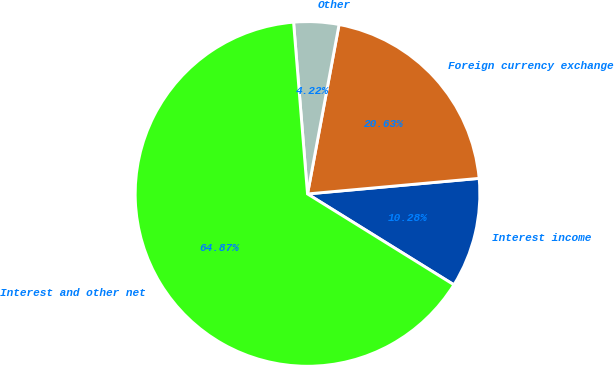Convert chart to OTSL. <chart><loc_0><loc_0><loc_500><loc_500><pie_chart><fcel>Interest income<fcel>Foreign currency exchange<fcel>Other<fcel>Interest and other net<nl><fcel>10.28%<fcel>20.63%<fcel>4.22%<fcel>64.87%<nl></chart> 